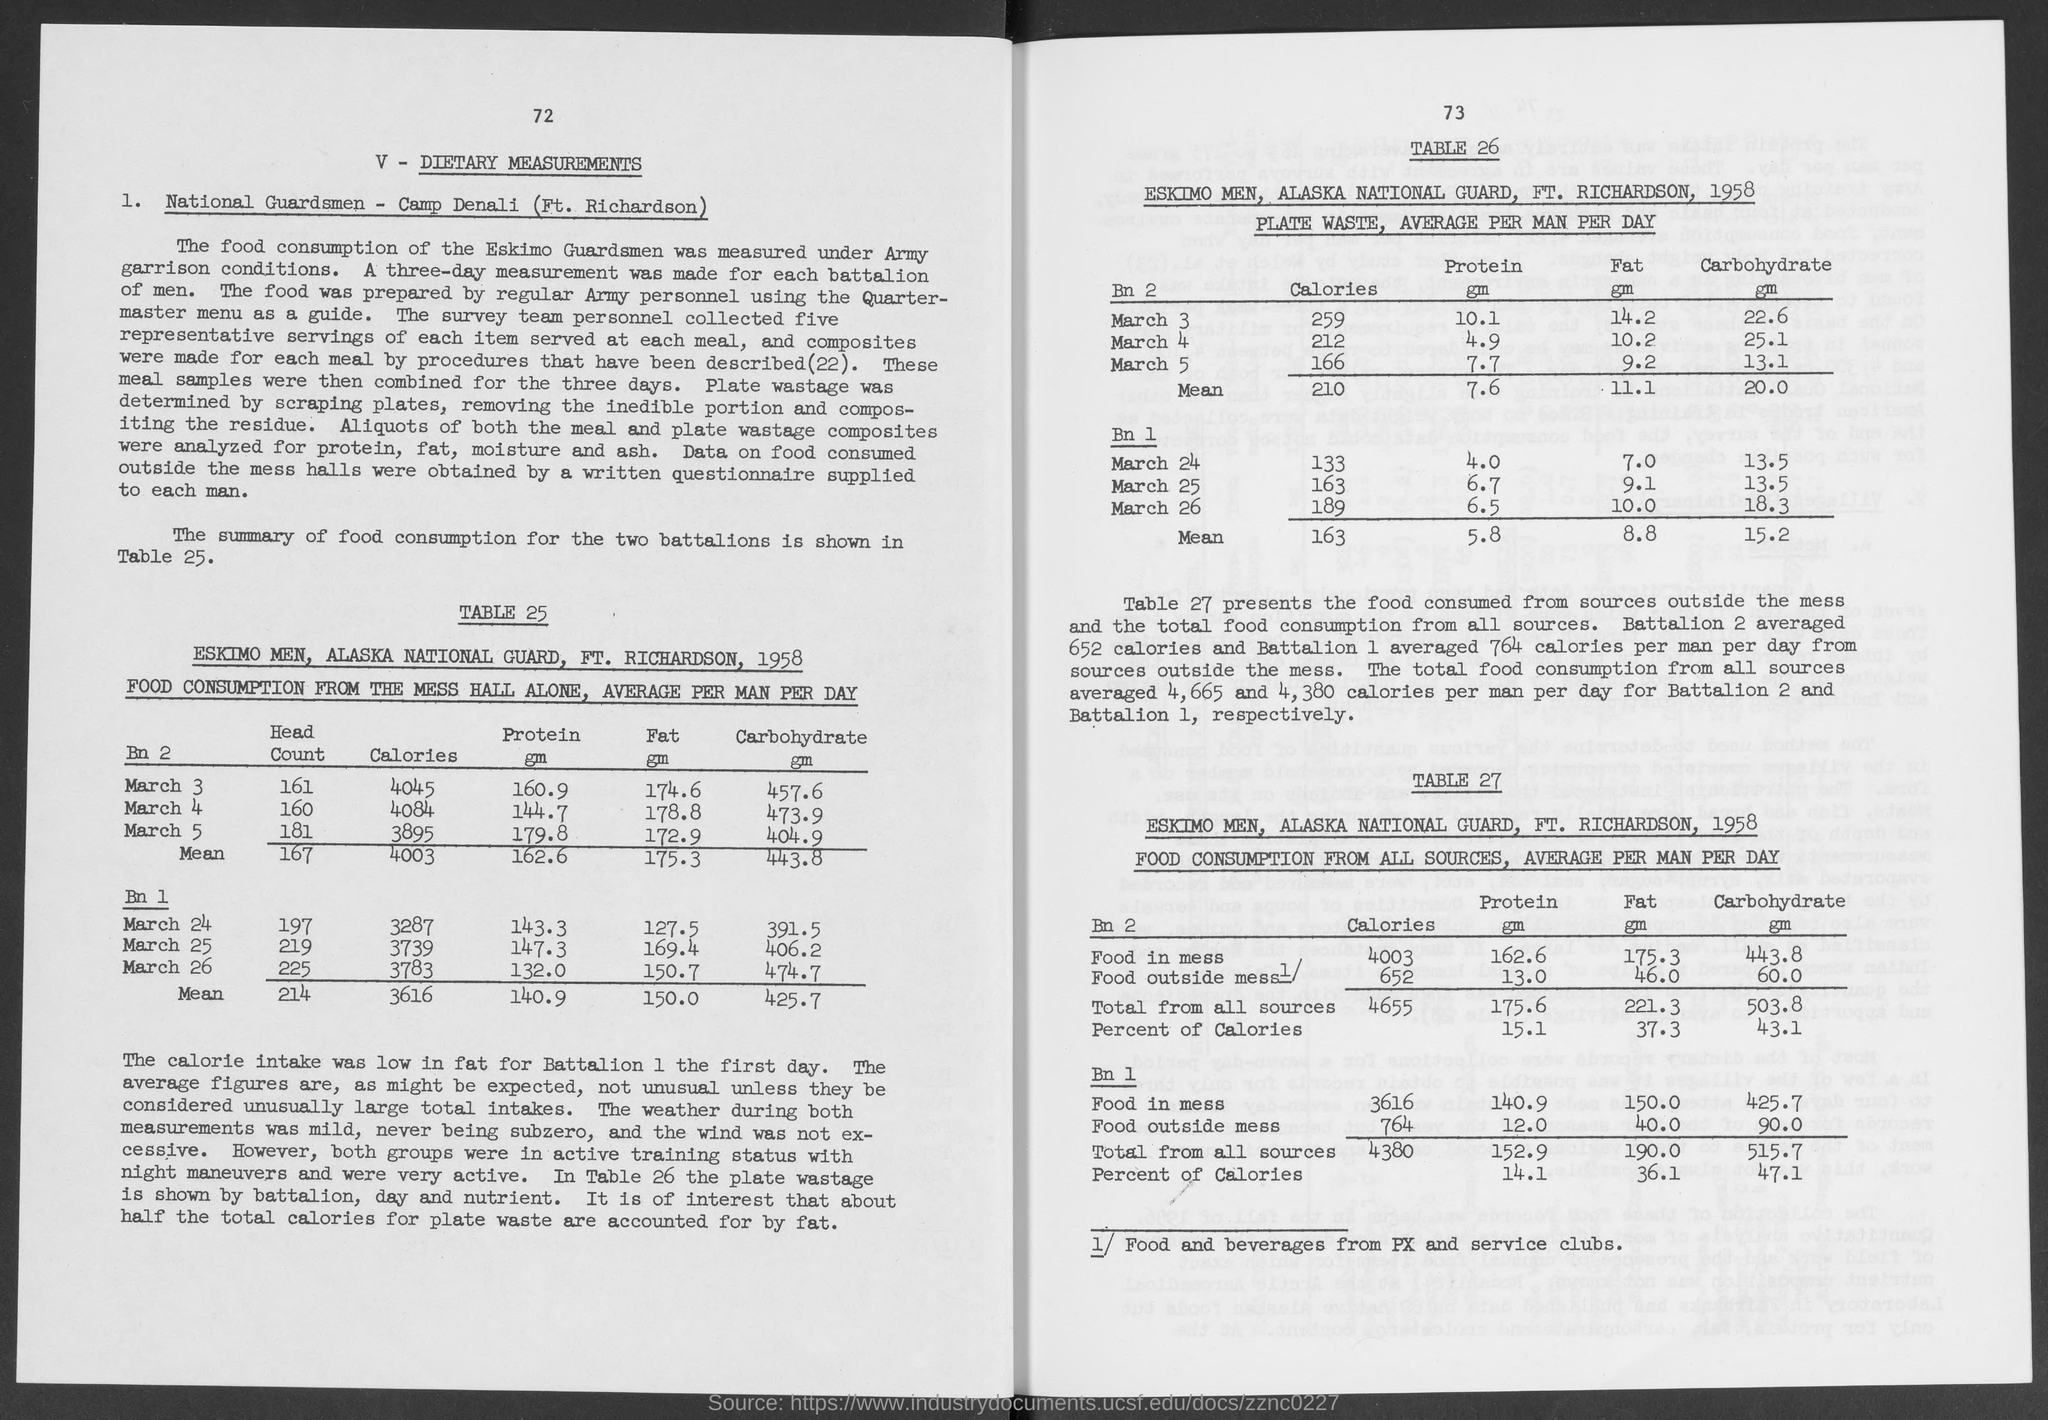Specify some key components in this picture. The number above dietary measurements is 72. 